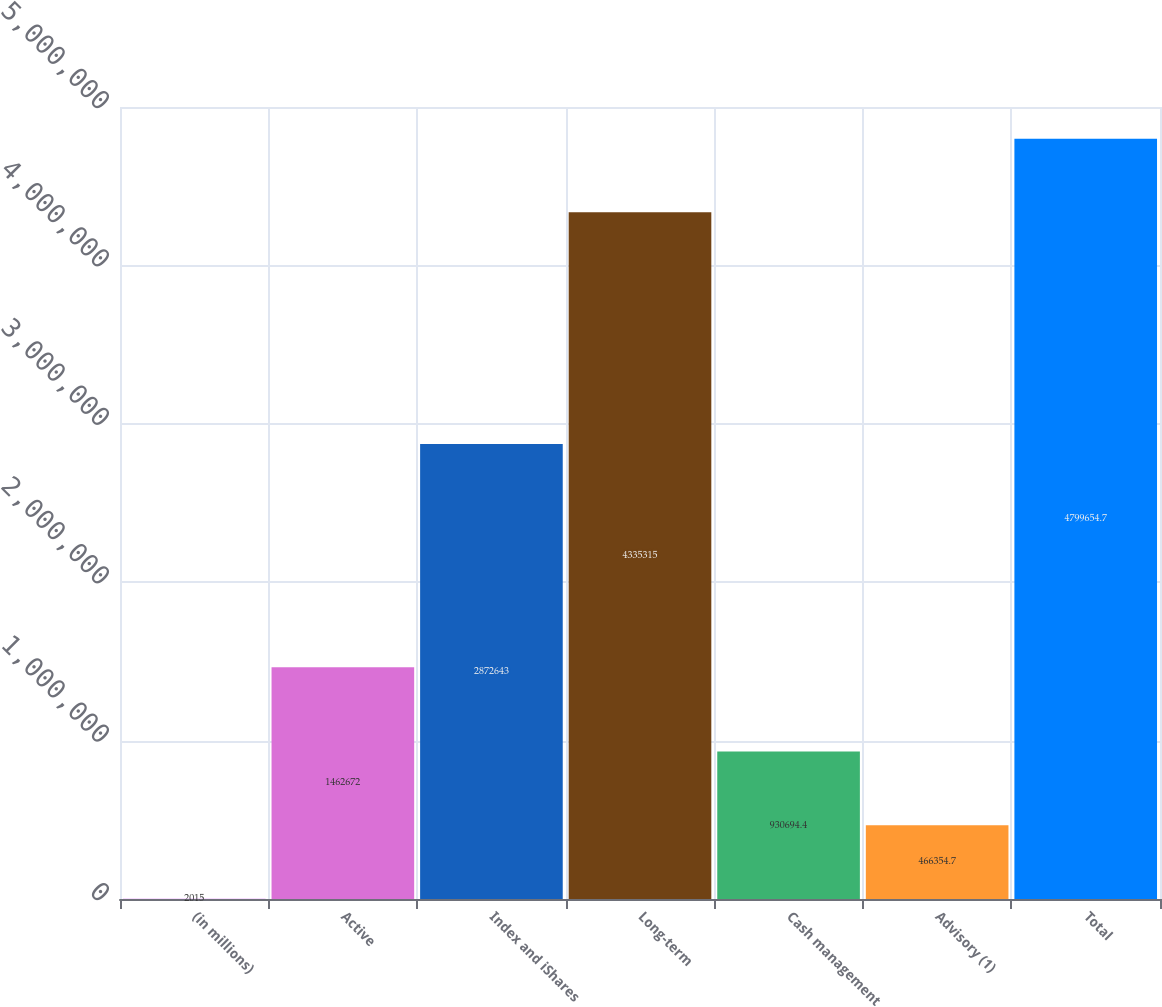Convert chart to OTSL. <chart><loc_0><loc_0><loc_500><loc_500><bar_chart><fcel>(in millions)<fcel>Active<fcel>Index and iShares<fcel>Long-term<fcel>Cash management<fcel>Advisory (1)<fcel>Total<nl><fcel>2015<fcel>1.46267e+06<fcel>2.87264e+06<fcel>4.33532e+06<fcel>930694<fcel>466355<fcel>4.79965e+06<nl></chart> 